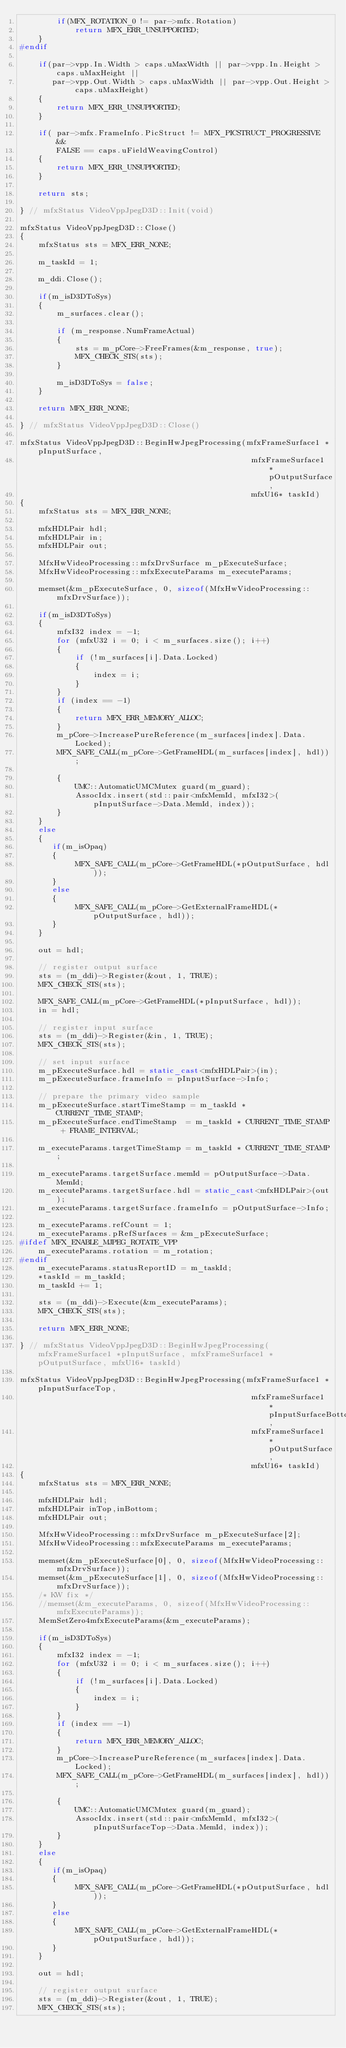Convert code to text. <code><loc_0><loc_0><loc_500><loc_500><_C++_>        if(MFX_ROTATION_0 != par->mfx.Rotation)
            return MFX_ERR_UNSUPPORTED;
    }
#endif

    if(par->vpp.In.Width > caps.uMaxWidth || par->vpp.In.Height > caps.uMaxHeight ||
       par->vpp.Out.Width > caps.uMaxWidth || par->vpp.Out.Height > caps.uMaxHeight)
    {
        return MFX_ERR_UNSUPPORTED;
    }

    if( par->mfx.FrameInfo.PicStruct != MFX_PICSTRUCT_PROGRESSIVE &&
        FALSE == caps.uFieldWeavingControl)
    {
        return MFX_ERR_UNSUPPORTED;
    }

    return sts;

} // mfxStatus VideoVppJpegD3D::Init(void)

mfxStatus VideoVppJpegD3D::Close()
{
    mfxStatus sts = MFX_ERR_NONE;

    m_taskId = 1;

    m_ddi.Close();

    if(m_isD3DToSys)
    {
        m_surfaces.clear();

        if (m_response.NumFrameActual)
        {
            sts = m_pCore->FreeFrames(&m_response, true);
            MFX_CHECK_STS(sts);
        }

        m_isD3DToSys = false;
    }

    return MFX_ERR_NONE;

} // mfxStatus VideoVppJpegD3D::Close()

mfxStatus VideoVppJpegD3D::BeginHwJpegProcessing(mfxFrameSurface1 *pInputSurface, 
                                                  mfxFrameSurface1 *pOutputSurface, 
                                                  mfxU16* taskId)
{
    mfxStatus sts = MFX_ERR_NONE;
    
    mfxHDLPair hdl;
    mfxHDLPair in;
    mfxHDLPair out;

    MfxHwVideoProcessing::mfxDrvSurface m_pExecuteSurface;
    MfxHwVideoProcessing::mfxExecuteParams m_executeParams;

    memset(&m_pExecuteSurface, 0, sizeof(MfxHwVideoProcessing::mfxDrvSurface));

    if(m_isD3DToSys)
    {
        mfxI32 index = -1; 
        for (mfxU32 i = 0; i < m_surfaces.size(); i++)
        {
            if (!m_surfaces[i].Data.Locked)
            {
                index = i;
            }
        }
        if (index == -1)
        {
            return MFX_ERR_MEMORY_ALLOC;
        }
        m_pCore->IncreasePureReference(m_surfaces[index].Data.Locked);
        MFX_SAFE_CALL(m_pCore->GetFrameHDL(m_surfaces[index], hdl));

        {
            UMC::AutomaticUMCMutex guard(m_guard);
            AssocIdx.insert(std::pair<mfxMemId, mfxI32>(pInputSurface->Data.MemId, index));
        }
    }
    else
    {
       if(m_isOpaq)
       {
            MFX_SAFE_CALL(m_pCore->GetFrameHDL(*pOutputSurface, hdl));
       }
       else
       {
            MFX_SAFE_CALL(m_pCore->GetExternalFrameHDL(*pOutputSurface, hdl));
       }
    }

    out = hdl;

    // register output surface
    sts = (m_ddi)->Register(&out, 1, TRUE);
    MFX_CHECK_STS(sts);

    MFX_SAFE_CALL(m_pCore->GetFrameHDL(*pInputSurface, hdl));
    in = hdl;

    // register input surface
    sts = (m_ddi)->Register(&in, 1, TRUE);
    MFX_CHECK_STS(sts);

    // set input surface
    m_pExecuteSurface.hdl = static_cast<mfxHDLPair>(in);
    m_pExecuteSurface.frameInfo = pInputSurface->Info;

    // prepare the primary video sample
    m_pExecuteSurface.startTimeStamp = m_taskId * CURRENT_TIME_STAMP;
    m_pExecuteSurface.endTimeStamp  = m_taskId * CURRENT_TIME_STAMP + FRAME_INTERVAL;
    
    m_executeParams.targetTimeStamp = m_taskId * CURRENT_TIME_STAMP;

    m_executeParams.targetSurface.memId = pOutputSurface->Data.MemId;
    m_executeParams.targetSurface.hdl = static_cast<mfxHDLPair>(out);
    m_executeParams.targetSurface.frameInfo = pOutputSurface->Info;

    m_executeParams.refCount = 1;
    m_executeParams.pRefSurfaces = &m_pExecuteSurface;
#ifdef MFX_ENABLE_MJPEG_ROTATE_VPP
    m_executeParams.rotation = m_rotation;
#endif
    m_executeParams.statusReportID = m_taskId;
    *taskId = m_taskId;
    m_taskId += 1;

    sts = (m_ddi)->Execute(&m_executeParams);
    MFX_CHECK_STS(sts);

    return MFX_ERR_NONE;

} // mfxStatus VideoVppJpegD3D::BeginHwJpegProcessing(mfxFrameSurface1 *pInputSurface, mfxFrameSurface1 *pOutputSurface, mfxU16* taskId)

mfxStatus VideoVppJpegD3D::BeginHwJpegProcessing(mfxFrameSurface1 *pInputSurfaceTop, 
                                                  mfxFrameSurface1 *pInputSurfaceBottom, 
                                                  mfxFrameSurface1 *pOutputSurface, 
                                                  mfxU16* taskId)
{
    mfxStatus sts = MFX_ERR_NONE;
    
    mfxHDLPair hdl;
    mfxHDLPair inTop,inBottom;
    mfxHDLPair out;

    MfxHwVideoProcessing::mfxDrvSurface m_pExecuteSurface[2];
    MfxHwVideoProcessing::mfxExecuteParams m_executeParams;

    memset(&m_pExecuteSurface[0], 0, sizeof(MfxHwVideoProcessing::mfxDrvSurface));
    memset(&m_pExecuteSurface[1], 0, sizeof(MfxHwVideoProcessing::mfxDrvSurface));
    /* KW fix */
    //memset(&m_executeParams, 0, sizeof(MfxHwVideoProcessing::mfxExecuteParams));
    MemSetZero4mfxExecuteParams(&m_executeParams);

    if(m_isD3DToSys)
    {
        mfxI32 index = -1; 
        for (mfxU32 i = 0; i < m_surfaces.size(); i++)
        {
            if (!m_surfaces[i].Data.Locked)
            {
                index = i;
            }
        }
        if (index == -1)
        {
            return MFX_ERR_MEMORY_ALLOC;
        }
        m_pCore->IncreasePureReference(m_surfaces[index].Data.Locked);
        MFX_SAFE_CALL(m_pCore->GetFrameHDL(m_surfaces[index], hdl));

        {
            UMC::AutomaticUMCMutex guard(m_guard);
            AssocIdx.insert(std::pair<mfxMemId, mfxI32>(pInputSurfaceTop->Data.MemId, index));
        }
    }
    else
    {
       if(m_isOpaq)
       {
            MFX_SAFE_CALL(m_pCore->GetFrameHDL(*pOutputSurface, hdl));
       }
       else
       {
            MFX_SAFE_CALL(m_pCore->GetExternalFrameHDL(*pOutputSurface, hdl));
       }
    }

    out = hdl;

    // register output surface
    sts = (m_ddi)->Register(&out, 1, TRUE);
    MFX_CHECK_STS(sts);
</code> 